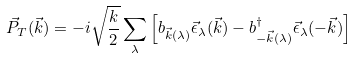Convert formula to latex. <formula><loc_0><loc_0><loc_500><loc_500>\vec { P } _ { T } ( \vec { k } ) = - i \sqrt { \frac { k } { 2 } } \sum _ { \lambda } \left [ b _ { \vec { k } ( \lambda ) } \vec { \epsilon } _ { \lambda } ( \vec { k } ) - b ^ { \dagger } _ { - \vec { k } ( \lambda ) } \vec { \epsilon } _ { \lambda } ( - \vec { k } ) \right ]</formula> 